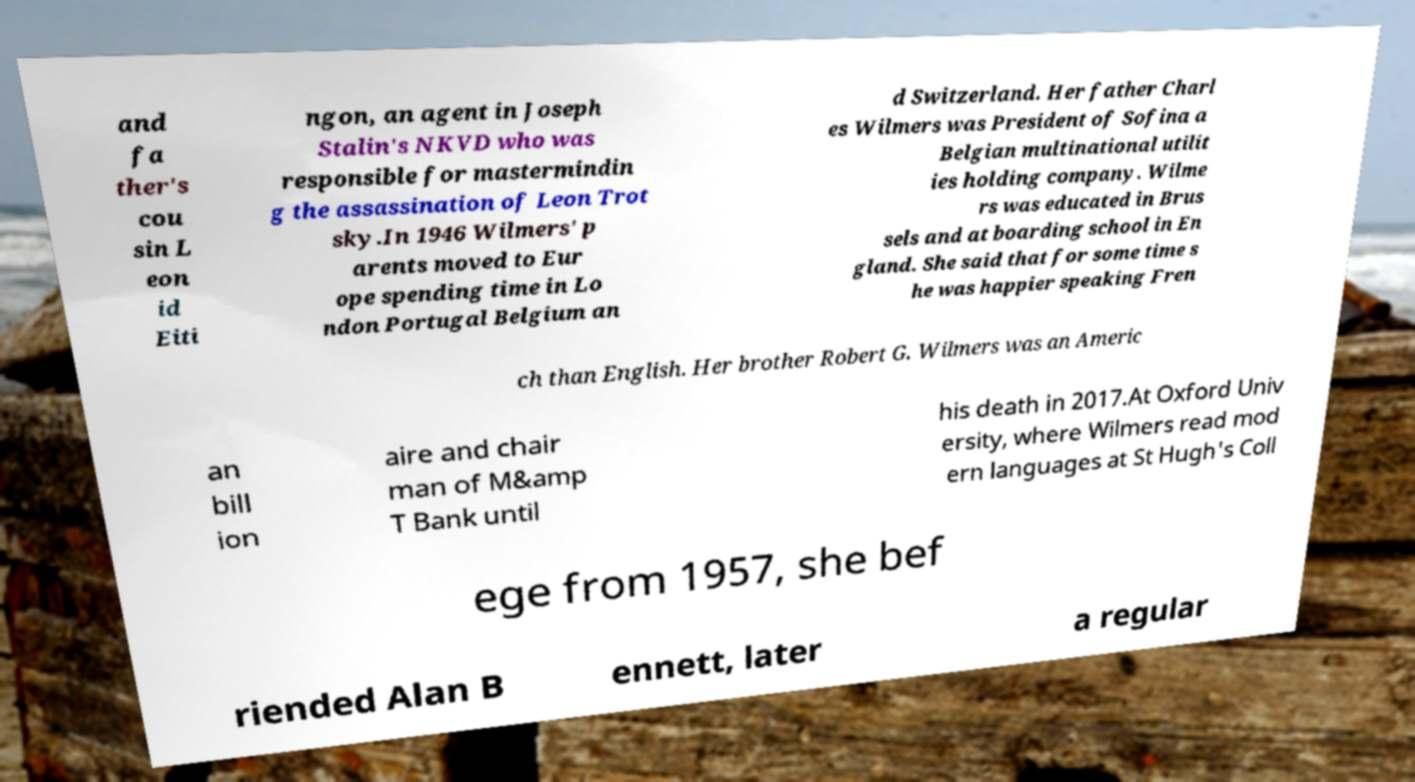Can you read and provide the text displayed in the image?This photo seems to have some interesting text. Can you extract and type it out for me? and fa ther's cou sin L eon id Eiti ngon, an agent in Joseph Stalin's NKVD who was responsible for mastermindin g the assassination of Leon Trot sky.In 1946 Wilmers' p arents moved to Eur ope spending time in Lo ndon Portugal Belgium an d Switzerland. Her father Charl es Wilmers was President of Sofina a Belgian multinational utilit ies holding company. Wilme rs was educated in Brus sels and at boarding school in En gland. She said that for some time s he was happier speaking Fren ch than English. Her brother Robert G. Wilmers was an Americ an bill ion aire and chair man of M&amp T Bank until his death in 2017.At Oxford Univ ersity, where Wilmers read mod ern languages at St Hugh's Coll ege from 1957, she bef riended Alan B ennett, later a regular 